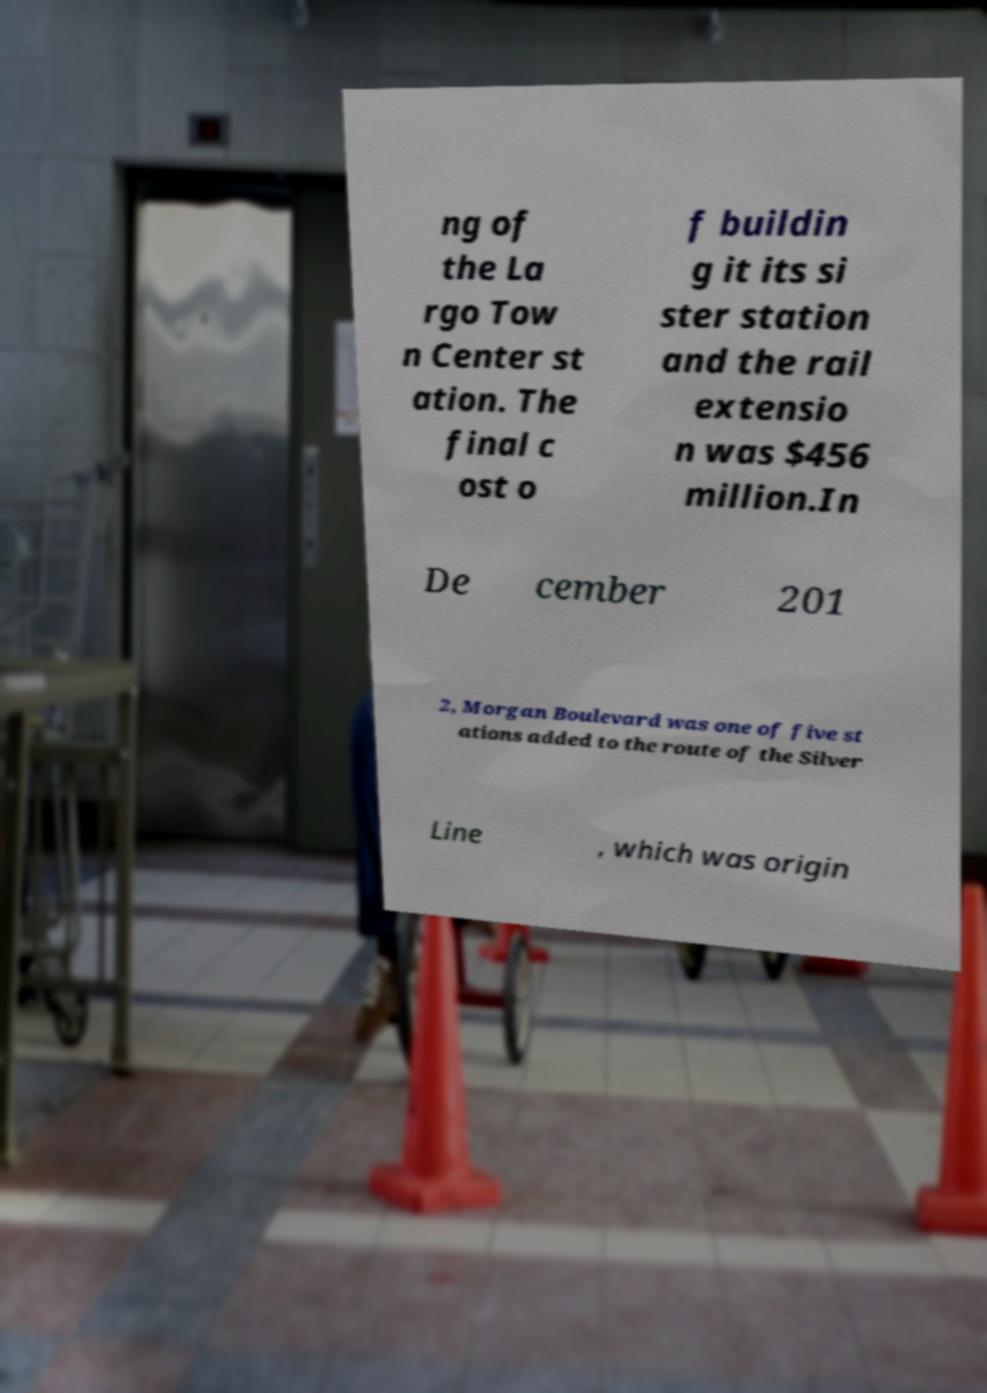Can you read and provide the text displayed in the image?This photo seems to have some interesting text. Can you extract and type it out for me? ng of the La rgo Tow n Center st ation. The final c ost o f buildin g it its si ster station and the rail extensio n was $456 million.In De cember 201 2, Morgan Boulevard was one of five st ations added to the route of the Silver Line , which was origin 